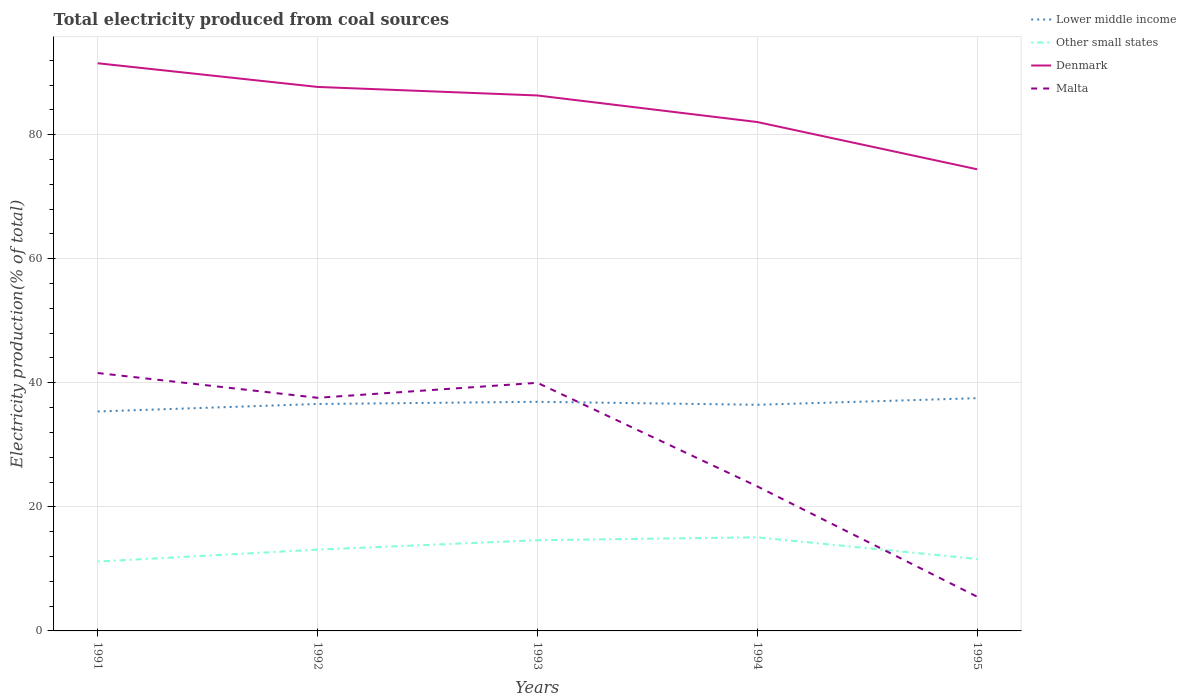Is the number of lines equal to the number of legend labels?
Offer a terse response. Yes. Across all years, what is the maximum total electricity produced in Denmark?
Your answer should be very brief. 74.42. In which year was the total electricity produced in Other small states maximum?
Provide a short and direct response. 1991. What is the total total electricity produced in Other small states in the graph?
Ensure brevity in your answer.  -1.52. What is the difference between the highest and the second highest total electricity produced in Other small states?
Offer a very short reply. 3.91. What is the difference between the highest and the lowest total electricity produced in Other small states?
Your response must be concise. 2. Is the total electricity produced in Malta strictly greater than the total electricity produced in Denmark over the years?
Offer a terse response. Yes. How many lines are there?
Offer a very short reply. 4. Where does the legend appear in the graph?
Ensure brevity in your answer.  Top right. How many legend labels are there?
Give a very brief answer. 4. How are the legend labels stacked?
Your answer should be very brief. Vertical. What is the title of the graph?
Ensure brevity in your answer.  Total electricity produced from coal sources. What is the label or title of the X-axis?
Your answer should be compact. Years. What is the Electricity production(% of total) in Lower middle income in 1991?
Provide a short and direct response. 35.38. What is the Electricity production(% of total) in Other small states in 1991?
Your answer should be very brief. 11.18. What is the Electricity production(% of total) in Denmark in 1991?
Keep it short and to the point. 91.52. What is the Electricity production(% of total) of Malta in 1991?
Ensure brevity in your answer.  41.58. What is the Electricity production(% of total) of Lower middle income in 1992?
Ensure brevity in your answer.  36.58. What is the Electricity production(% of total) of Other small states in 1992?
Provide a short and direct response. 13.11. What is the Electricity production(% of total) of Denmark in 1992?
Provide a succinct answer. 87.7. What is the Electricity production(% of total) in Malta in 1992?
Your answer should be very brief. 37.58. What is the Electricity production(% of total) of Lower middle income in 1993?
Give a very brief answer. 36.94. What is the Electricity production(% of total) of Other small states in 1993?
Your response must be concise. 14.62. What is the Electricity production(% of total) in Denmark in 1993?
Your answer should be compact. 86.32. What is the Electricity production(% of total) in Lower middle income in 1994?
Provide a short and direct response. 36.46. What is the Electricity production(% of total) of Other small states in 1994?
Your response must be concise. 15.09. What is the Electricity production(% of total) of Denmark in 1994?
Give a very brief answer. 82.04. What is the Electricity production(% of total) of Malta in 1994?
Provide a short and direct response. 23.3. What is the Electricity production(% of total) of Lower middle income in 1995?
Your response must be concise. 37.52. What is the Electricity production(% of total) in Other small states in 1995?
Give a very brief answer. 11.59. What is the Electricity production(% of total) in Denmark in 1995?
Give a very brief answer. 74.42. What is the Electricity production(% of total) of Malta in 1995?
Give a very brief answer. 5.51. Across all years, what is the maximum Electricity production(% of total) in Lower middle income?
Ensure brevity in your answer.  37.52. Across all years, what is the maximum Electricity production(% of total) of Other small states?
Offer a terse response. 15.09. Across all years, what is the maximum Electricity production(% of total) of Denmark?
Provide a short and direct response. 91.52. Across all years, what is the maximum Electricity production(% of total) of Malta?
Give a very brief answer. 41.58. Across all years, what is the minimum Electricity production(% of total) of Lower middle income?
Provide a succinct answer. 35.38. Across all years, what is the minimum Electricity production(% of total) in Other small states?
Offer a very short reply. 11.18. Across all years, what is the minimum Electricity production(% of total) of Denmark?
Provide a succinct answer. 74.42. Across all years, what is the minimum Electricity production(% of total) of Malta?
Provide a short and direct response. 5.51. What is the total Electricity production(% of total) of Lower middle income in the graph?
Make the answer very short. 182.88. What is the total Electricity production(% of total) in Other small states in the graph?
Provide a succinct answer. 65.6. What is the total Electricity production(% of total) of Denmark in the graph?
Your answer should be very brief. 422. What is the total Electricity production(% of total) of Malta in the graph?
Your answer should be compact. 147.97. What is the difference between the Electricity production(% of total) in Lower middle income in 1991 and that in 1992?
Offer a very short reply. -1.21. What is the difference between the Electricity production(% of total) in Other small states in 1991 and that in 1992?
Your response must be concise. -1.92. What is the difference between the Electricity production(% of total) of Denmark in 1991 and that in 1992?
Keep it short and to the point. 3.82. What is the difference between the Electricity production(% of total) of Malta in 1991 and that in 1992?
Make the answer very short. 3.99. What is the difference between the Electricity production(% of total) of Lower middle income in 1991 and that in 1993?
Your answer should be very brief. -1.56. What is the difference between the Electricity production(% of total) of Other small states in 1991 and that in 1993?
Offer a terse response. -3.44. What is the difference between the Electricity production(% of total) in Denmark in 1991 and that in 1993?
Provide a short and direct response. 5.2. What is the difference between the Electricity production(% of total) of Malta in 1991 and that in 1993?
Make the answer very short. 1.58. What is the difference between the Electricity production(% of total) of Lower middle income in 1991 and that in 1994?
Offer a very short reply. -1.08. What is the difference between the Electricity production(% of total) of Other small states in 1991 and that in 1994?
Give a very brief answer. -3.91. What is the difference between the Electricity production(% of total) of Denmark in 1991 and that in 1994?
Your answer should be compact. 9.48. What is the difference between the Electricity production(% of total) in Malta in 1991 and that in 1994?
Provide a succinct answer. 18.28. What is the difference between the Electricity production(% of total) in Lower middle income in 1991 and that in 1995?
Your response must be concise. -2.14. What is the difference between the Electricity production(% of total) of Other small states in 1991 and that in 1995?
Offer a terse response. -0.41. What is the difference between the Electricity production(% of total) of Denmark in 1991 and that in 1995?
Your response must be concise. 17.1. What is the difference between the Electricity production(% of total) of Malta in 1991 and that in 1995?
Keep it short and to the point. 36.06. What is the difference between the Electricity production(% of total) of Lower middle income in 1992 and that in 1993?
Make the answer very short. -0.35. What is the difference between the Electricity production(% of total) in Other small states in 1992 and that in 1993?
Ensure brevity in your answer.  -1.52. What is the difference between the Electricity production(% of total) of Denmark in 1992 and that in 1993?
Make the answer very short. 1.38. What is the difference between the Electricity production(% of total) in Malta in 1992 and that in 1993?
Make the answer very short. -2.42. What is the difference between the Electricity production(% of total) in Lower middle income in 1992 and that in 1994?
Your answer should be very brief. 0.13. What is the difference between the Electricity production(% of total) of Other small states in 1992 and that in 1994?
Keep it short and to the point. -1.99. What is the difference between the Electricity production(% of total) of Denmark in 1992 and that in 1994?
Your response must be concise. 5.66. What is the difference between the Electricity production(% of total) in Malta in 1992 and that in 1994?
Offer a terse response. 14.29. What is the difference between the Electricity production(% of total) of Lower middle income in 1992 and that in 1995?
Make the answer very short. -0.94. What is the difference between the Electricity production(% of total) in Other small states in 1992 and that in 1995?
Provide a succinct answer. 1.51. What is the difference between the Electricity production(% of total) of Denmark in 1992 and that in 1995?
Provide a short and direct response. 13.28. What is the difference between the Electricity production(% of total) of Malta in 1992 and that in 1995?
Offer a very short reply. 32.07. What is the difference between the Electricity production(% of total) in Lower middle income in 1993 and that in 1994?
Your answer should be very brief. 0.48. What is the difference between the Electricity production(% of total) of Other small states in 1993 and that in 1994?
Ensure brevity in your answer.  -0.47. What is the difference between the Electricity production(% of total) of Denmark in 1993 and that in 1994?
Provide a short and direct response. 4.28. What is the difference between the Electricity production(% of total) of Malta in 1993 and that in 1994?
Offer a terse response. 16.7. What is the difference between the Electricity production(% of total) of Lower middle income in 1993 and that in 1995?
Your answer should be very brief. -0.58. What is the difference between the Electricity production(% of total) in Other small states in 1993 and that in 1995?
Keep it short and to the point. 3.03. What is the difference between the Electricity production(% of total) of Malta in 1993 and that in 1995?
Keep it short and to the point. 34.49. What is the difference between the Electricity production(% of total) in Lower middle income in 1994 and that in 1995?
Your response must be concise. -1.06. What is the difference between the Electricity production(% of total) of Other small states in 1994 and that in 1995?
Offer a very short reply. 3.5. What is the difference between the Electricity production(% of total) in Denmark in 1994 and that in 1995?
Ensure brevity in your answer.  7.62. What is the difference between the Electricity production(% of total) of Malta in 1994 and that in 1995?
Offer a very short reply. 17.78. What is the difference between the Electricity production(% of total) in Lower middle income in 1991 and the Electricity production(% of total) in Other small states in 1992?
Give a very brief answer. 22.27. What is the difference between the Electricity production(% of total) of Lower middle income in 1991 and the Electricity production(% of total) of Denmark in 1992?
Your answer should be compact. -52.32. What is the difference between the Electricity production(% of total) in Lower middle income in 1991 and the Electricity production(% of total) in Malta in 1992?
Your answer should be compact. -2.21. What is the difference between the Electricity production(% of total) of Other small states in 1991 and the Electricity production(% of total) of Denmark in 1992?
Offer a terse response. -76.52. What is the difference between the Electricity production(% of total) of Other small states in 1991 and the Electricity production(% of total) of Malta in 1992?
Your answer should be compact. -26.4. What is the difference between the Electricity production(% of total) of Denmark in 1991 and the Electricity production(% of total) of Malta in 1992?
Give a very brief answer. 53.93. What is the difference between the Electricity production(% of total) of Lower middle income in 1991 and the Electricity production(% of total) of Other small states in 1993?
Offer a very short reply. 20.76. What is the difference between the Electricity production(% of total) of Lower middle income in 1991 and the Electricity production(% of total) of Denmark in 1993?
Your response must be concise. -50.94. What is the difference between the Electricity production(% of total) in Lower middle income in 1991 and the Electricity production(% of total) in Malta in 1993?
Offer a very short reply. -4.62. What is the difference between the Electricity production(% of total) of Other small states in 1991 and the Electricity production(% of total) of Denmark in 1993?
Your response must be concise. -75.14. What is the difference between the Electricity production(% of total) in Other small states in 1991 and the Electricity production(% of total) in Malta in 1993?
Offer a terse response. -28.82. What is the difference between the Electricity production(% of total) in Denmark in 1991 and the Electricity production(% of total) in Malta in 1993?
Make the answer very short. 51.52. What is the difference between the Electricity production(% of total) of Lower middle income in 1991 and the Electricity production(% of total) of Other small states in 1994?
Your answer should be compact. 20.29. What is the difference between the Electricity production(% of total) of Lower middle income in 1991 and the Electricity production(% of total) of Denmark in 1994?
Your response must be concise. -46.66. What is the difference between the Electricity production(% of total) of Lower middle income in 1991 and the Electricity production(% of total) of Malta in 1994?
Provide a succinct answer. 12.08. What is the difference between the Electricity production(% of total) in Other small states in 1991 and the Electricity production(% of total) in Denmark in 1994?
Your answer should be compact. -70.86. What is the difference between the Electricity production(% of total) of Other small states in 1991 and the Electricity production(% of total) of Malta in 1994?
Provide a succinct answer. -12.11. What is the difference between the Electricity production(% of total) in Denmark in 1991 and the Electricity production(% of total) in Malta in 1994?
Make the answer very short. 68.22. What is the difference between the Electricity production(% of total) in Lower middle income in 1991 and the Electricity production(% of total) in Other small states in 1995?
Your answer should be very brief. 23.79. What is the difference between the Electricity production(% of total) of Lower middle income in 1991 and the Electricity production(% of total) of Denmark in 1995?
Provide a succinct answer. -39.04. What is the difference between the Electricity production(% of total) in Lower middle income in 1991 and the Electricity production(% of total) in Malta in 1995?
Offer a terse response. 29.86. What is the difference between the Electricity production(% of total) in Other small states in 1991 and the Electricity production(% of total) in Denmark in 1995?
Your answer should be very brief. -63.24. What is the difference between the Electricity production(% of total) of Other small states in 1991 and the Electricity production(% of total) of Malta in 1995?
Make the answer very short. 5.67. What is the difference between the Electricity production(% of total) in Denmark in 1991 and the Electricity production(% of total) in Malta in 1995?
Make the answer very short. 86. What is the difference between the Electricity production(% of total) of Lower middle income in 1992 and the Electricity production(% of total) of Other small states in 1993?
Offer a very short reply. 21.96. What is the difference between the Electricity production(% of total) in Lower middle income in 1992 and the Electricity production(% of total) in Denmark in 1993?
Your response must be concise. -49.74. What is the difference between the Electricity production(% of total) of Lower middle income in 1992 and the Electricity production(% of total) of Malta in 1993?
Your response must be concise. -3.42. What is the difference between the Electricity production(% of total) in Other small states in 1992 and the Electricity production(% of total) in Denmark in 1993?
Provide a succinct answer. -73.21. What is the difference between the Electricity production(% of total) in Other small states in 1992 and the Electricity production(% of total) in Malta in 1993?
Make the answer very short. -26.89. What is the difference between the Electricity production(% of total) in Denmark in 1992 and the Electricity production(% of total) in Malta in 1993?
Your answer should be compact. 47.7. What is the difference between the Electricity production(% of total) in Lower middle income in 1992 and the Electricity production(% of total) in Other small states in 1994?
Offer a very short reply. 21.49. What is the difference between the Electricity production(% of total) of Lower middle income in 1992 and the Electricity production(% of total) of Denmark in 1994?
Your answer should be compact. -45.45. What is the difference between the Electricity production(% of total) in Lower middle income in 1992 and the Electricity production(% of total) in Malta in 1994?
Ensure brevity in your answer.  13.29. What is the difference between the Electricity production(% of total) of Other small states in 1992 and the Electricity production(% of total) of Denmark in 1994?
Provide a succinct answer. -68.93. What is the difference between the Electricity production(% of total) in Other small states in 1992 and the Electricity production(% of total) in Malta in 1994?
Offer a terse response. -10.19. What is the difference between the Electricity production(% of total) of Denmark in 1992 and the Electricity production(% of total) of Malta in 1994?
Make the answer very short. 64.4. What is the difference between the Electricity production(% of total) of Lower middle income in 1992 and the Electricity production(% of total) of Other small states in 1995?
Ensure brevity in your answer.  24.99. What is the difference between the Electricity production(% of total) of Lower middle income in 1992 and the Electricity production(% of total) of Denmark in 1995?
Keep it short and to the point. -37.84. What is the difference between the Electricity production(% of total) of Lower middle income in 1992 and the Electricity production(% of total) of Malta in 1995?
Offer a terse response. 31.07. What is the difference between the Electricity production(% of total) of Other small states in 1992 and the Electricity production(% of total) of Denmark in 1995?
Give a very brief answer. -61.31. What is the difference between the Electricity production(% of total) in Other small states in 1992 and the Electricity production(% of total) in Malta in 1995?
Offer a terse response. 7.59. What is the difference between the Electricity production(% of total) of Denmark in 1992 and the Electricity production(% of total) of Malta in 1995?
Make the answer very short. 82.18. What is the difference between the Electricity production(% of total) of Lower middle income in 1993 and the Electricity production(% of total) of Other small states in 1994?
Give a very brief answer. 21.84. What is the difference between the Electricity production(% of total) of Lower middle income in 1993 and the Electricity production(% of total) of Denmark in 1994?
Offer a terse response. -45.1. What is the difference between the Electricity production(% of total) in Lower middle income in 1993 and the Electricity production(% of total) in Malta in 1994?
Offer a very short reply. 13.64. What is the difference between the Electricity production(% of total) of Other small states in 1993 and the Electricity production(% of total) of Denmark in 1994?
Make the answer very short. -67.42. What is the difference between the Electricity production(% of total) of Other small states in 1993 and the Electricity production(% of total) of Malta in 1994?
Give a very brief answer. -8.67. What is the difference between the Electricity production(% of total) in Denmark in 1993 and the Electricity production(% of total) in Malta in 1994?
Give a very brief answer. 63.03. What is the difference between the Electricity production(% of total) in Lower middle income in 1993 and the Electricity production(% of total) in Other small states in 1995?
Offer a very short reply. 25.34. What is the difference between the Electricity production(% of total) in Lower middle income in 1993 and the Electricity production(% of total) in Denmark in 1995?
Provide a short and direct response. -37.48. What is the difference between the Electricity production(% of total) of Lower middle income in 1993 and the Electricity production(% of total) of Malta in 1995?
Your answer should be very brief. 31.42. What is the difference between the Electricity production(% of total) of Other small states in 1993 and the Electricity production(% of total) of Denmark in 1995?
Provide a short and direct response. -59.8. What is the difference between the Electricity production(% of total) in Other small states in 1993 and the Electricity production(% of total) in Malta in 1995?
Your response must be concise. 9.11. What is the difference between the Electricity production(% of total) of Denmark in 1993 and the Electricity production(% of total) of Malta in 1995?
Provide a short and direct response. 80.81. What is the difference between the Electricity production(% of total) of Lower middle income in 1994 and the Electricity production(% of total) of Other small states in 1995?
Make the answer very short. 24.86. What is the difference between the Electricity production(% of total) in Lower middle income in 1994 and the Electricity production(% of total) in Denmark in 1995?
Your answer should be very brief. -37.97. What is the difference between the Electricity production(% of total) in Lower middle income in 1994 and the Electricity production(% of total) in Malta in 1995?
Your answer should be very brief. 30.94. What is the difference between the Electricity production(% of total) in Other small states in 1994 and the Electricity production(% of total) in Denmark in 1995?
Give a very brief answer. -59.33. What is the difference between the Electricity production(% of total) of Other small states in 1994 and the Electricity production(% of total) of Malta in 1995?
Make the answer very short. 9.58. What is the difference between the Electricity production(% of total) of Denmark in 1994 and the Electricity production(% of total) of Malta in 1995?
Provide a short and direct response. 76.52. What is the average Electricity production(% of total) of Lower middle income per year?
Offer a very short reply. 36.58. What is the average Electricity production(% of total) in Other small states per year?
Offer a terse response. 13.12. What is the average Electricity production(% of total) of Denmark per year?
Provide a short and direct response. 84.4. What is the average Electricity production(% of total) of Malta per year?
Give a very brief answer. 29.59. In the year 1991, what is the difference between the Electricity production(% of total) in Lower middle income and Electricity production(% of total) in Other small states?
Give a very brief answer. 24.19. In the year 1991, what is the difference between the Electricity production(% of total) in Lower middle income and Electricity production(% of total) in Denmark?
Your answer should be very brief. -56.14. In the year 1991, what is the difference between the Electricity production(% of total) of Lower middle income and Electricity production(% of total) of Malta?
Provide a succinct answer. -6.2. In the year 1991, what is the difference between the Electricity production(% of total) in Other small states and Electricity production(% of total) in Denmark?
Give a very brief answer. -80.33. In the year 1991, what is the difference between the Electricity production(% of total) of Other small states and Electricity production(% of total) of Malta?
Your response must be concise. -30.39. In the year 1991, what is the difference between the Electricity production(% of total) in Denmark and Electricity production(% of total) in Malta?
Offer a very short reply. 49.94. In the year 1992, what is the difference between the Electricity production(% of total) in Lower middle income and Electricity production(% of total) in Other small states?
Offer a very short reply. 23.48. In the year 1992, what is the difference between the Electricity production(% of total) of Lower middle income and Electricity production(% of total) of Denmark?
Give a very brief answer. -51.11. In the year 1992, what is the difference between the Electricity production(% of total) in Lower middle income and Electricity production(% of total) in Malta?
Provide a short and direct response. -1. In the year 1992, what is the difference between the Electricity production(% of total) of Other small states and Electricity production(% of total) of Denmark?
Your answer should be very brief. -74.59. In the year 1992, what is the difference between the Electricity production(% of total) in Other small states and Electricity production(% of total) in Malta?
Offer a very short reply. -24.48. In the year 1992, what is the difference between the Electricity production(% of total) in Denmark and Electricity production(% of total) in Malta?
Ensure brevity in your answer.  50.12. In the year 1993, what is the difference between the Electricity production(% of total) in Lower middle income and Electricity production(% of total) in Other small states?
Your answer should be very brief. 22.32. In the year 1993, what is the difference between the Electricity production(% of total) of Lower middle income and Electricity production(% of total) of Denmark?
Give a very brief answer. -49.38. In the year 1993, what is the difference between the Electricity production(% of total) of Lower middle income and Electricity production(% of total) of Malta?
Offer a terse response. -3.06. In the year 1993, what is the difference between the Electricity production(% of total) of Other small states and Electricity production(% of total) of Denmark?
Offer a terse response. -71.7. In the year 1993, what is the difference between the Electricity production(% of total) in Other small states and Electricity production(% of total) in Malta?
Keep it short and to the point. -25.38. In the year 1993, what is the difference between the Electricity production(% of total) in Denmark and Electricity production(% of total) in Malta?
Your answer should be compact. 46.32. In the year 1994, what is the difference between the Electricity production(% of total) of Lower middle income and Electricity production(% of total) of Other small states?
Your response must be concise. 21.36. In the year 1994, what is the difference between the Electricity production(% of total) in Lower middle income and Electricity production(% of total) in Denmark?
Your answer should be compact. -45.58. In the year 1994, what is the difference between the Electricity production(% of total) in Lower middle income and Electricity production(% of total) in Malta?
Offer a terse response. 13.16. In the year 1994, what is the difference between the Electricity production(% of total) in Other small states and Electricity production(% of total) in Denmark?
Make the answer very short. -66.95. In the year 1994, what is the difference between the Electricity production(% of total) of Other small states and Electricity production(% of total) of Malta?
Your answer should be very brief. -8.2. In the year 1994, what is the difference between the Electricity production(% of total) in Denmark and Electricity production(% of total) in Malta?
Provide a succinct answer. 58.74. In the year 1995, what is the difference between the Electricity production(% of total) in Lower middle income and Electricity production(% of total) in Other small states?
Ensure brevity in your answer.  25.93. In the year 1995, what is the difference between the Electricity production(% of total) in Lower middle income and Electricity production(% of total) in Denmark?
Offer a very short reply. -36.9. In the year 1995, what is the difference between the Electricity production(% of total) in Lower middle income and Electricity production(% of total) in Malta?
Provide a short and direct response. 32.01. In the year 1995, what is the difference between the Electricity production(% of total) of Other small states and Electricity production(% of total) of Denmark?
Your answer should be compact. -62.83. In the year 1995, what is the difference between the Electricity production(% of total) of Other small states and Electricity production(% of total) of Malta?
Make the answer very short. 6.08. In the year 1995, what is the difference between the Electricity production(% of total) of Denmark and Electricity production(% of total) of Malta?
Offer a terse response. 68.91. What is the ratio of the Electricity production(% of total) of Lower middle income in 1991 to that in 1992?
Your answer should be compact. 0.97. What is the ratio of the Electricity production(% of total) in Other small states in 1991 to that in 1992?
Give a very brief answer. 0.85. What is the ratio of the Electricity production(% of total) in Denmark in 1991 to that in 1992?
Provide a succinct answer. 1.04. What is the ratio of the Electricity production(% of total) of Malta in 1991 to that in 1992?
Offer a terse response. 1.11. What is the ratio of the Electricity production(% of total) in Lower middle income in 1991 to that in 1993?
Provide a succinct answer. 0.96. What is the ratio of the Electricity production(% of total) in Other small states in 1991 to that in 1993?
Your answer should be very brief. 0.76. What is the ratio of the Electricity production(% of total) of Denmark in 1991 to that in 1993?
Make the answer very short. 1.06. What is the ratio of the Electricity production(% of total) of Malta in 1991 to that in 1993?
Your answer should be compact. 1.04. What is the ratio of the Electricity production(% of total) in Lower middle income in 1991 to that in 1994?
Offer a terse response. 0.97. What is the ratio of the Electricity production(% of total) in Other small states in 1991 to that in 1994?
Offer a terse response. 0.74. What is the ratio of the Electricity production(% of total) of Denmark in 1991 to that in 1994?
Keep it short and to the point. 1.12. What is the ratio of the Electricity production(% of total) of Malta in 1991 to that in 1994?
Offer a very short reply. 1.78. What is the ratio of the Electricity production(% of total) of Lower middle income in 1991 to that in 1995?
Provide a short and direct response. 0.94. What is the ratio of the Electricity production(% of total) in Other small states in 1991 to that in 1995?
Offer a terse response. 0.96. What is the ratio of the Electricity production(% of total) of Denmark in 1991 to that in 1995?
Your answer should be compact. 1.23. What is the ratio of the Electricity production(% of total) of Malta in 1991 to that in 1995?
Provide a succinct answer. 7.54. What is the ratio of the Electricity production(% of total) of Lower middle income in 1992 to that in 1993?
Keep it short and to the point. 0.99. What is the ratio of the Electricity production(% of total) in Other small states in 1992 to that in 1993?
Keep it short and to the point. 0.9. What is the ratio of the Electricity production(% of total) in Malta in 1992 to that in 1993?
Ensure brevity in your answer.  0.94. What is the ratio of the Electricity production(% of total) of Other small states in 1992 to that in 1994?
Provide a short and direct response. 0.87. What is the ratio of the Electricity production(% of total) in Denmark in 1992 to that in 1994?
Keep it short and to the point. 1.07. What is the ratio of the Electricity production(% of total) of Malta in 1992 to that in 1994?
Provide a short and direct response. 1.61. What is the ratio of the Electricity production(% of total) of Lower middle income in 1992 to that in 1995?
Offer a very short reply. 0.98. What is the ratio of the Electricity production(% of total) in Other small states in 1992 to that in 1995?
Give a very brief answer. 1.13. What is the ratio of the Electricity production(% of total) of Denmark in 1992 to that in 1995?
Offer a very short reply. 1.18. What is the ratio of the Electricity production(% of total) in Malta in 1992 to that in 1995?
Provide a succinct answer. 6.82. What is the ratio of the Electricity production(% of total) of Lower middle income in 1993 to that in 1994?
Your answer should be compact. 1.01. What is the ratio of the Electricity production(% of total) of Other small states in 1993 to that in 1994?
Provide a succinct answer. 0.97. What is the ratio of the Electricity production(% of total) of Denmark in 1993 to that in 1994?
Give a very brief answer. 1.05. What is the ratio of the Electricity production(% of total) of Malta in 1993 to that in 1994?
Your answer should be very brief. 1.72. What is the ratio of the Electricity production(% of total) of Lower middle income in 1993 to that in 1995?
Offer a terse response. 0.98. What is the ratio of the Electricity production(% of total) in Other small states in 1993 to that in 1995?
Ensure brevity in your answer.  1.26. What is the ratio of the Electricity production(% of total) in Denmark in 1993 to that in 1995?
Ensure brevity in your answer.  1.16. What is the ratio of the Electricity production(% of total) in Malta in 1993 to that in 1995?
Your response must be concise. 7.25. What is the ratio of the Electricity production(% of total) in Lower middle income in 1994 to that in 1995?
Your answer should be compact. 0.97. What is the ratio of the Electricity production(% of total) in Other small states in 1994 to that in 1995?
Offer a terse response. 1.3. What is the ratio of the Electricity production(% of total) in Denmark in 1994 to that in 1995?
Your answer should be compact. 1.1. What is the ratio of the Electricity production(% of total) of Malta in 1994 to that in 1995?
Your response must be concise. 4.22. What is the difference between the highest and the second highest Electricity production(% of total) in Lower middle income?
Keep it short and to the point. 0.58. What is the difference between the highest and the second highest Electricity production(% of total) in Other small states?
Your response must be concise. 0.47. What is the difference between the highest and the second highest Electricity production(% of total) in Denmark?
Offer a terse response. 3.82. What is the difference between the highest and the second highest Electricity production(% of total) in Malta?
Keep it short and to the point. 1.58. What is the difference between the highest and the lowest Electricity production(% of total) in Lower middle income?
Make the answer very short. 2.14. What is the difference between the highest and the lowest Electricity production(% of total) of Other small states?
Provide a short and direct response. 3.91. What is the difference between the highest and the lowest Electricity production(% of total) in Denmark?
Offer a very short reply. 17.1. What is the difference between the highest and the lowest Electricity production(% of total) of Malta?
Provide a short and direct response. 36.06. 